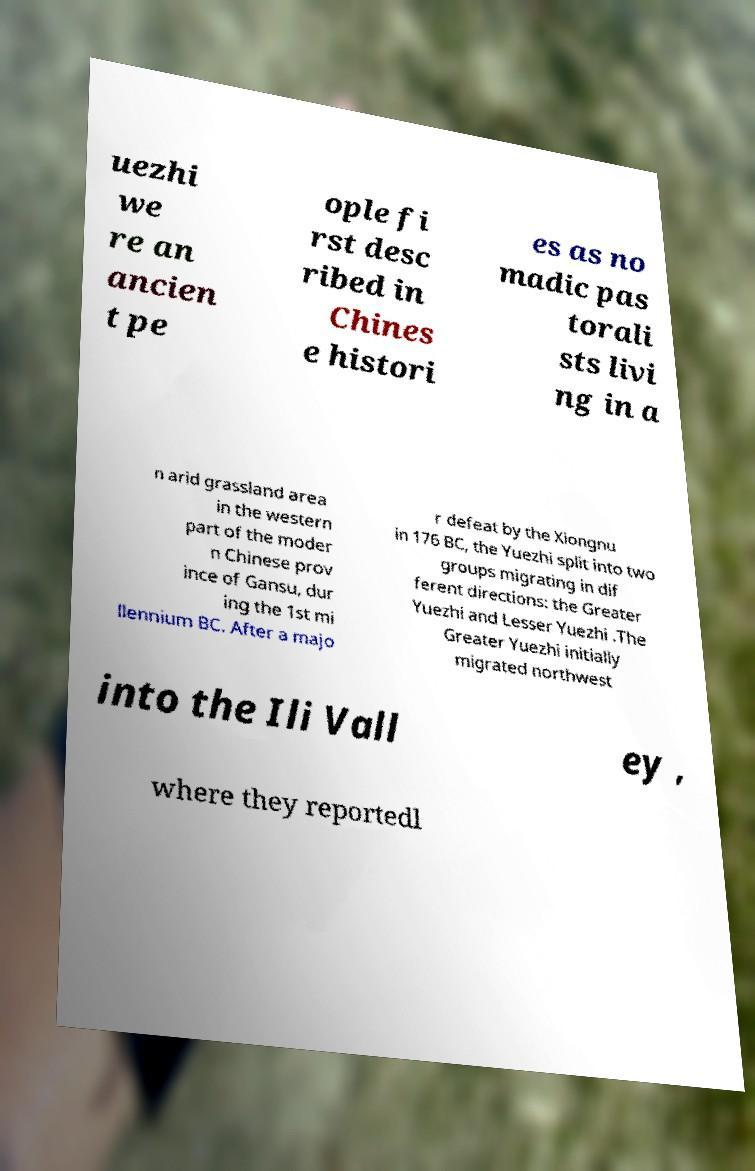Please identify and transcribe the text found in this image. uezhi we re an ancien t pe ople fi rst desc ribed in Chines e histori es as no madic pas torali sts livi ng in a n arid grassland area in the western part of the moder n Chinese prov ince of Gansu, dur ing the 1st mi llennium BC. After a majo r defeat by the Xiongnu in 176 BC, the Yuezhi split into two groups migrating in dif ferent directions: the Greater Yuezhi and Lesser Yuezhi .The Greater Yuezhi initially migrated northwest into the Ili Vall ey , where they reportedl 